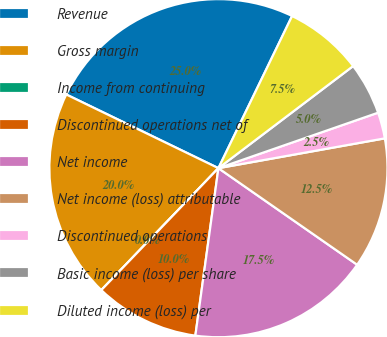<chart> <loc_0><loc_0><loc_500><loc_500><pie_chart><fcel>Revenue<fcel>Gross margin<fcel>Income from continuing<fcel>Discontinued operations net of<fcel>Net income<fcel>Net income (loss) attributable<fcel>Discontinued operations<fcel>Basic income (loss) per share<fcel>Diluted income (loss) per<nl><fcel>25.0%<fcel>20.0%<fcel>0.0%<fcel>10.0%<fcel>17.5%<fcel>12.5%<fcel>2.5%<fcel>5.0%<fcel>7.5%<nl></chart> 